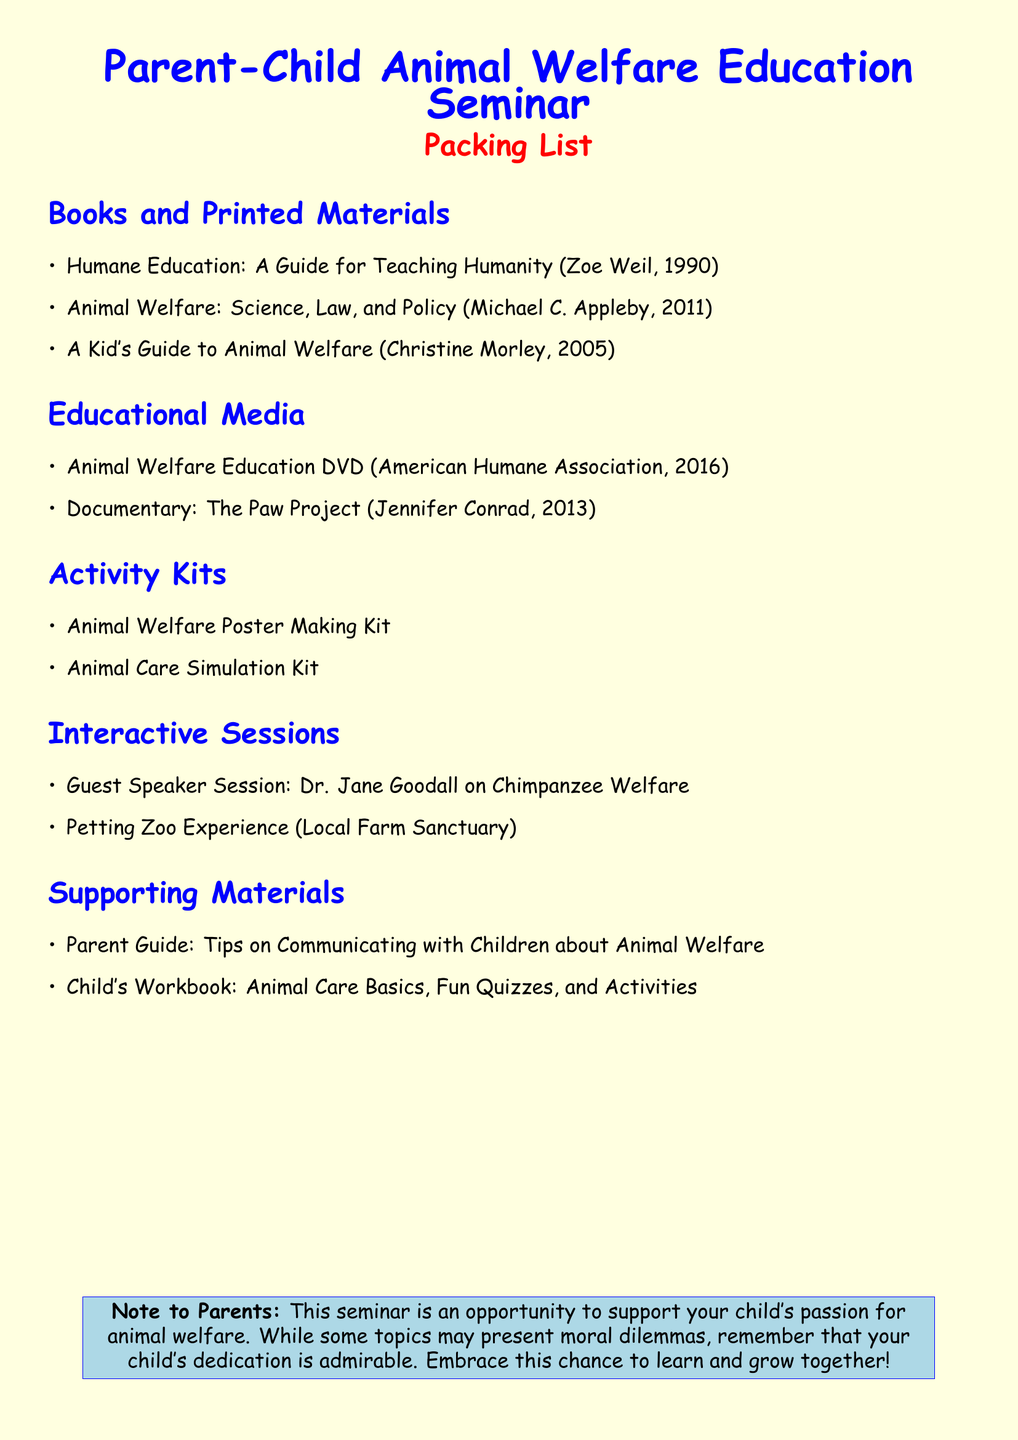What is the name of the guide for teaching humanity? The document lists "Humane Education: A Guide for Teaching Humanity" as one of the books.
Answer: Humane Education: A Guide for Teaching Humanity Who is the guest speaker at the seminar? The document identifies Dr. Jane Goodall as the guest speaker for the session on Chimpanzee welfare.
Answer: Dr. Jane Goodall What year was the Animal Welfare DVD released? The document states that the Animal Welfare Education DVD was released in 2016.
Answer: 2016 What type of experience is included in the interactive sessions? The document mentions a Petting Zoo Experience as part of the interactive sessions.
Answer: Petting Zoo Experience How many books are listed in the Books and Printed Materials section? There are three titles mentioned in the Books and Printed Materials section of the document.
Answer: 3 What is one of the materials included in the Activity Kits? The document includes "Animal Care Simulation Kit" as one of the kits listed under Activity Kits.
Answer: Animal Care Simulation Kit What color is the page background? The document specifies that the page background color is light yellow.
Answer: light yellow What is a key theme of the note to parents? The note encourages parents to support their child's passion for animal welfare while acknowledging moral dilemmas.
Answer: Support your child's passion for animal welfare 